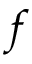<formula> <loc_0><loc_0><loc_500><loc_500>f</formula> 